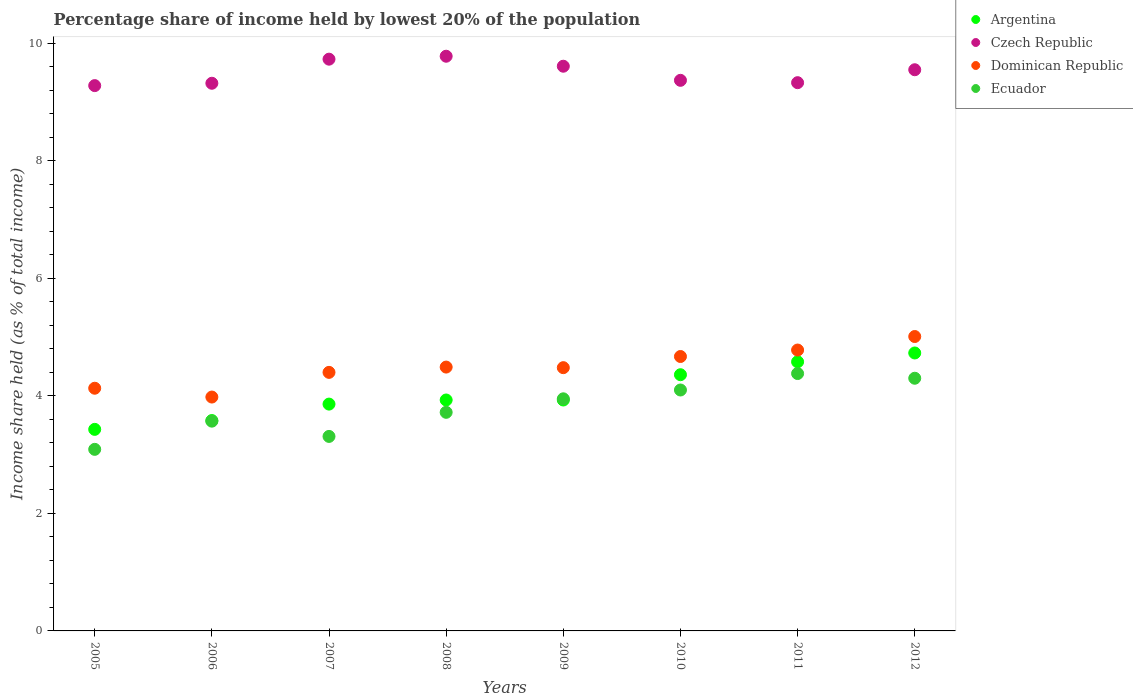Is the number of dotlines equal to the number of legend labels?
Offer a terse response. Yes. What is the percentage share of income held by lowest 20% of the population in Dominican Republic in 2006?
Keep it short and to the point. 3.98. Across all years, what is the maximum percentage share of income held by lowest 20% of the population in Czech Republic?
Keep it short and to the point. 9.78. Across all years, what is the minimum percentage share of income held by lowest 20% of the population in Ecuador?
Offer a very short reply. 3.09. In which year was the percentage share of income held by lowest 20% of the population in Argentina maximum?
Ensure brevity in your answer.  2012. What is the total percentage share of income held by lowest 20% of the population in Argentina in the graph?
Offer a very short reply. 32.4. What is the difference between the percentage share of income held by lowest 20% of the population in Czech Republic in 2006 and that in 2010?
Offer a terse response. -0.05. What is the difference between the percentage share of income held by lowest 20% of the population in Ecuador in 2011 and the percentage share of income held by lowest 20% of the population in Czech Republic in 2009?
Ensure brevity in your answer.  -5.23. What is the average percentage share of income held by lowest 20% of the population in Czech Republic per year?
Ensure brevity in your answer.  9.5. In the year 2008, what is the difference between the percentage share of income held by lowest 20% of the population in Czech Republic and percentage share of income held by lowest 20% of the population in Dominican Republic?
Provide a short and direct response. 5.29. What is the ratio of the percentage share of income held by lowest 20% of the population in Ecuador in 2005 to that in 2010?
Your answer should be very brief. 0.75. Is the percentage share of income held by lowest 20% of the population in Argentina in 2007 less than that in 2011?
Your answer should be very brief. Yes. What is the difference between the highest and the second highest percentage share of income held by lowest 20% of the population in Ecuador?
Your answer should be compact. 0.08. What is the difference between the highest and the lowest percentage share of income held by lowest 20% of the population in Ecuador?
Your answer should be compact. 1.29. In how many years, is the percentage share of income held by lowest 20% of the population in Ecuador greater than the average percentage share of income held by lowest 20% of the population in Ecuador taken over all years?
Offer a terse response. 4. Is the sum of the percentage share of income held by lowest 20% of the population in Argentina in 2005 and 2007 greater than the maximum percentage share of income held by lowest 20% of the population in Ecuador across all years?
Your answer should be compact. Yes. Is it the case that in every year, the sum of the percentage share of income held by lowest 20% of the population in Ecuador and percentage share of income held by lowest 20% of the population in Czech Republic  is greater than the sum of percentage share of income held by lowest 20% of the population in Dominican Republic and percentage share of income held by lowest 20% of the population in Argentina?
Provide a short and direct response. Yes. Does the percentage share of income held by lowest 20% of the population in Dominican Republic monotonically increase over the years?
Ensure brevity in your answer.  No. How many years are there in the graph?
Your answer should be compact. 8. What is the difference between two consecutive major ticks on the Y-axis?
Make the answer very short. 2. Does the graph contain grids?
Ensure brevity in your answer.  No. How are the legend labels stacked?
Ensure brevity in your answer.  Vertical. What is the title of the graph?
Make the answer very short. Percentage share of income held by lowest 20% of the population. What is the label or title of the X-axis?
Offer a terse response. Years. What is the label or title of the Y-axis?
Offer a terse response. Income share held (as % of total income). What is the Income share held (as % of total income) of Argentina in 2005?
Give a very brief answer. 3.43. What is the Income share held (as % of total income) of Czech Republic in 2005?
Your response must be concise. 9.28. What is the Income share held (as % of total income) of Dominican Republic in 2005?
Make the answer very short. 4.13. What is the Income share held (as % of total income) of Ecuador in 2005?
Offer a terse response. 3.09. What is the Income share held (as % of total income) of Argentina in 2006?
Your response must be concise. 3.58. What is the Income share held (as % of total income) of Czech Republic in 2006?
Give a very brief answer. 9.32. What is the Income share held (as % of total income) in Dominican Republic in 2006?
Give a very brief answer. 3.98. What is the Income share held (as % of total income) in Ecuador in 2006?
Provide a succinct answer. 3.57. What is the Income share held (as % of total income) of Argentina in 2007?
Provide a short and direct response. 3.86. What is the Income share held (as % of total income) of Czech Republic in 2007?
Your answer should be very brief. 9.73. What is the Income share held (as % of total income) of Ecuador in 2007?
Offer a terse response. 3.31. What is the Income share held (as % of total income) in Argentina in 2008?
Give a very brief answer. 3.93. What is the Income share held (as % of total income) in Czech Republic in 2008?
Ensure brevity in your answer.  9.78. What is the Income share held (as % of total income) of Dominican Republic in 2008?
Keep it short and to the point. 4.49. What is the Income share held (as % of total income) in Ecuador in 2008?
Ensure brevity in your answer.  3.72. What is the Income share held (as % of total income) of Argentina in 2009?
Ensure brevity in your answer.  3.93. What is the Income share held (as % of total income) in Czech Republic in 2009?
Your answer should be compact. 9.61. What is the Income share held (as % of total income) of Dominican Republic in 2009?
Provide a short and direct response. 4.48. What is the Income share held (as % of total income) of Ecuador in 2009?
Provide a short and direct response. 3.95. What is the Income share held (as % of total income) in Argentina in 2010?
Keep it short and to the point. 4.36. What is the Income share held (as % of total income) of Czech Republic in 2010?
Keep it short and to the point. 9.37. What is the Income share held (as % of total income) of Dominican Republic in 2010?
Give a very brief answer. 4.67. What is the Income share held (as % of total income) in Argentina in 2011?
Your answer should be very brief. 4.58. What is the Income share held (as % of total income) of Czech Republic in 2011?
Your answer should be compact. 9.33. What is the Income share held (as % of total income) of Dominican Republic in 2011?
Your response must be concise. 4.78. What is the Income share held (as % of total income) in Ecuador in 2011?
Give a very brief answer. 4.38. What is the Income share held (as % of total income) in Argentina in 2012?
Provide a short and direct response. 4.73. What is the Income share held (as % of total income) in Czech Republic in 2012?
Your answer should be very brief. 9.55. What is the Income share held (as % of total income) in Dominican Republic in 2012?
Give a very brief answer. 5.01. What is the Income share held (as % of total income) in Ecuador in 2012?
Your answer should be very brief. 4.3. Across all years, what is the maximum Income share held (as % of total income) of Argentina?
Offer a very short reply. 4.73. Across all years, what is the maximum Income share held (as % of total income) of Czech Republic?
Your answer should be compact. 9.78. Across all years, what is the maximum Income share held (as % of total income) of Dominican Republic?
Offer a terse response. 5.01. Across all years, what is the maximum Income share held (as % of total income) of Ecuador?
Ensure brevity in your answer.  4.38. Across all years, what is the minimum Income share held (as % of total income) of Argentina?
Offer a terse response. 3.43. Across all years, what is the minimum Income share held (as % of total income) of Czech Republic?
Keep it short and to the point. 9.28. Across all years, what is the minimum Income share held (as % of total income) of Dominican Republic?
Provide a succinct answer. 3.98. Across all years, what is the minimum Income share held (as % of total income) of Ecuador?
Your answer should be compact. 3.09. What is the total Income share held (as % of total income) of Argentina in the graph?
Provide a succinct answer. 32.4. What is the total Income share held (as % of total income) of Czech Republic in the graph?
Provide a short and direct response. 75.97. What is the total Income share held (as % of total income) of Dominican Republic in the graph?
Offer a very short reply. 35.94. What is the total Income share held (as % of total income) in Ecuador in the graph?
Your answer should be very brief. 30.42. What is the difference between the Income share held (as % of total income) of Argentina in 2005 and that in 2006?
Your answer should be very brief. -0.15. What is the difference between the Income share held (as % of total income) of Czech Republic in 2005 and that in 2006?
Give a very brief answer. -0.04. What is the difference between the Income share held (as % of total income) of Dominican Republic in 2005 and that in 2006?
Provide a short and direct response. 0.15. What is the difference between the Income share held (as % of total income) of Ecuador in 2005 and that in 2006?
Your response must be concise. -0.48. What is the difference between the Income share held (as % of total income) of Argentina in 2005 and that in 2007?
Make the answer very short. -0.43. What is the difference between the Income share held (as % of total income) of Czech Republic in 2005 and that in 2007?
Your answer should be compact. -0.45. What is the difference between the Income share held (as % of total income) of Dominican Republic in 2005 and that in 2007?
Make the answer very short. -0.27. What is the difference between the Income share held (as % of total income) of Ecuador in 2005 and that in 2007?
Your response must be concise. -0.22. What is the difference between the Income share held (as % of total income) in Argentina in 2005 and that in 2008?
Offer a very short reply. -0.5. What is the difference between the Income share held (as % of total income) in Czech Republic in 2005 and that in 2008?
Offer a terse response. -0.5. What is the difference between the Income share held (as % of total income) of Dominican Republic in 2005 and that in 2008?
Your response must be concise. -0.36. What is the difference between the Income share held (as % of total income) of Ecuador in 2005 and that in 2008?
Provide a short and direct response. -0.63. What is the difference between the Income share held (as % of total income) in Czech Republic in 2005 and that in 2009?
Your answer should be compact. -0.33. What is the difference between the Income share held (as % of total income) of Dominican Republic in 2005 and that in 2009?
Provide a succinct answer. -0.35. What is the difference between the Income share held (as % of total income) of Ecuador in 2005 and that in 2009?
Provide a succinct answer. -0.86. What is the difference between the Income share held (as % of total income) in Argentina in 2005 and that in 2010?
Give a very brief answer. -0.93. What is the difference between the Income share held (as % of total income) in Czech Republic in 2005 and that in 2010?
Make the answer very short. -0.09. What is the difference between the Income share held (as % of total income) of Dominican Republic in 2005 and that in 2010?
Make the answer very short. -0.54. What is the difference between the Income share held (as % of total income) of Ecuador in 2005 and that in 2010?
Your response must be concise. -1.01. What is the difference between the Income share held (as % of total income) of Argentina in 2005 and that in 2011?
Make the answer very short. -1.15. What is the difference between the Income share held (as % of total income) in Dominican Republic in 2005 and that in 2011?
Provide a succinct answer. -0.65. What is the difference between the Income share held (as % of total income) in Ecuador in 2005 and that in 2011?
Make the answer very short. -1.29. What is the difference between the Income share held (as % of total income) of Czech Republic in 2005 and that in 2012?
Keep it short and to the point. -0.27. What is the difference between the Income share held (as % of total income) of Dominican Republic in 2005 and that in 2012?
Make the answer very short. -0.88. What is the difference between the Income share held (as % of total income) of Ecuador in 2005 and that in 2012?
Keep it short and to the point. -1.21. What is the difference between the Income share held (as % of total income) in Argentina in 2006 and that in 2007?
Offer a very short reply. -0.28. What is the difference between the Income share held (as % of total income) of Czech Republic in 2006 and that in 2007?
Provide a short and direct response. -0.41. What is the difference between the Income share held (as % of total income) of Dominican Republic in 2006 and that in 2007?
Offer a terse response. -0.42. What is the difference between the Income share held (as % of total income) in Ecuador in 2006 and that in 2007?
Your answer should be very brief. 0.26. What is the difference between the Income share held (as % of total income) of Argentina in 2006 and that in 2008?
Give a very brief answer. -0.35. What is the difference between the Income share held (as % of total income) of Czech Republic in 2006 and that in 2008?
Offer a terse response. -0.46. What is the difference between the Income share held (as % of total income) in Dominican Republic in 2006 and that in 2008?
Provide a short and direct response. -0.51. What is the difference between the Income share held (as % of total income) of Argentina in 2006 and that in 2009?
Your answer should be compact. -0.35. What is the difference between the Income share held (as % of total income) in Czech Republic in 2006 and that in 2009?
Give a very brief answer. -0.29. What is the difference between the Income share held (as % of total income) of Ecuador in 2006 and that in 2009?
Offer a terse response. -0.38. What is the difference between the Income share held (as % of total income) of Argentina in 2006 and that in 2010?
Ensure brevity in your answer.  -0.78. What is the difference between the Income share held (as % of total income) in Dominican Republic in 2006 and that in 2010?
Your answer should be compact. -0.69. What is the difference between the Income share held (as % of total income) of Ecuador in 2006 and that in 2010?
Make the answer very short. -0.53. What is the difference between the Income share held (as % of total income) in Argentina in 2006 and that in 2011?
Offer a very short reply. -1. What is the difference between the Income share held (as % of total income) of Czech Republic in 2006 and that in 2011?
Provide a succinct answer. -0.01. What is the difference between the Income share held (as % of total income) in Dominican Republic in 2006 and that in 2011?
Your response must be concise. -0.8. What is the difference between the Income share held (as % of total income) of Ecuador in 2006 and that in 2011?
Provide a short and direct response. -0.81. What is the difference between the Income share held (as % of total income) of Argentina in 2006 and that in 2012?
Your response must be concise. -1.15. What is the difference between the Income share held (as % of total income) of Czech Republic in 2006 and that in 2012?
Ensure brevity in your answer.  -0.23. What is the difference between the Income share held (as % of total income) of Dominican Republic in 2006 and that in 2012?
Your answer should be very brief. -1.03. What is the difference between the Income share held (as % of total income) in Ecuador in 2006 and that in 2012?
Offer a very short reply. -0.73. What is the difference between the Income share held (as % of total income) in Argentina in 2007 and that in 2008?
Offer a very short reply. -0.07. What is the difference between the Income share held (as % of total income) of Dominican Republic in 2007 and that in 2008?
Your answer should be compact. -0.09. What is the difference between the Income share held (as % of total income) in Ecuador in 2007 and that in 2008?
Ensure brevity in your answer.  -0.41. What is the difference between the Income share held (as % of total income) of Argentina in 2007 and that in 2009?
Your answer should be compact. -0.07. What is the difference between the Income share held (as % of total income) in Czech Republic in 2007 and that in 2009?
Your answer should be compact. 0.12. What is the difference between the Income share held (as % of total income) of Dominican Republic in 2007 and that in 2009?
Make the answer very short. -0.08. What is the difference between the Income share held (as % of total income) of Ecuador in 2007 and that in 2009?
Keep it short and to the point. -0.64. What is the difference between the Income share held (as % of total income) in Argentina in 2007 and that in 2010?
Provide a succinct answer. -0.5. What is the difference between the Income share held (as % of total income) in Czech Republic in 2007 and that in 2010?
Offer a very short reply. 0.36. What is the difference between the Income share held (as % of total income) of Dominican Republic in 2007 and that in 2010?
Keep it short and to the point. -0.27. What is the difference between the Income share held (as % of total income) of Ecuador in 2007 and that in 2010?
Make the answer very short. -0.79. What is the difference between the Income share held (as % of total income) of Argentina in 2007 and that in 2011?
Give a very brief answer. -0.72. What is the difference between the Income share held (as % of total income) in Dominican Republic in 2007 and that in 2011?
Provide a succinct answer. -0.38. What is the difference between the Income share held (as % of total income) in Ecuador in 2007 and that in 2011?
Keep it short and to the point. -1.07. What is the difference between the Income share held (as % of total income) of Argentina in 2007 and that in 2012?
Provide a short and direct response. -0.87. What is the difference between the Income share held (as % of total income) of Czech Republic in 2007 and that in 2012?
Keep it short and to the point. 0.18. What is the difference between the Income share held (as % of total income) in Dominican Republic in 2007 and that in 2012?
Provide a short and direct response. -0.61. What is the difference between the Income share held (as % of total income) of Ecuador in 2007 and that in 2012?
Your answer should be compact. -0.99. What is the difference between the Income share held (as % of total income) of Czech Republic in 2008 and that in 2009?
Your response must be concise. 0.17. What is the difference between the Income share held (as % of total income) in Dominican Republic in 2008 and that in 2009?
Your answer should be compact. 0.01. What is the difference between the Income share held (as % of total income) in Ecuador in 2008 and that in 2009?
Provide a short and direct response. -0.23. What is the difference between the Income share held (as % of total income) of Argentina in 2008 and that in 2010?
Keep it short and to the point. -0.43. What is the difference between the Income share held (as % of total income) of Czech Republic in 2008 and that in 2010?
Give a very brief answer. 0.41. What is the difference between the Income share held (as % of total income) of Dominican Republic in 2008 and that in 2010?
Provide a short and direct response. -0.18. What is the difference between the Income share held (as % of total income) in Ecuador in 2008 and that in 2010?
Provide a short and direct response. -0.38. What is the difference between the Income share held (as % of total income) of Argentina in 2008 and that in 2011?
Offer a very short reply. -0.65. What is the difference between the Income share held (as % of total income) of Czech Republic in 2008 and that in 2011?
Your response must be concise. 0.45. What is the difference between the Income share held (as % of total income) in Dominican Republic in 2008 and that in 2011?
Keep it short and to the point. -0.29. What is the difference between the Income share held (as % of total income) in Ecuador in 2008 and that in 2011?
Your answer should be very brief. -0.66. What is the difference between the Income share held (as % of total income) of Czech Republic in 2008 and that in 2012?
Your answer should be very brief. 0.23. What is the difference between the Income share held (as % of total income) of Dominican Republic in 2008 and that in 2012?
Your answer should be very brief. -0.52. What is the difference between the Income share held (as % of total income) in Ecuador in 2008 and that in 2012?
Provide a succinct answer. -0.58. What is the difference between the Income share held (as % of total income) of Argentina in 2009 and that in 2010?
Your answer should be very brief. -0.43. What is the difference between the Income share held (as % of total income) in Czech Republic in 2009 and that in 2010?
Make the answer very short. 0.24. What is the difference between the Income share held (as % of total income) in Dominican Republic in 2009 and that in 2010?
Your answer should be very brief. -0.19. What is the difference between the Income share held (as % of total income) in Argentina in 2009 and that in 2011?
Offer a terse response. -0.65. What is the difference between the Income share held (as % of total income) in Czech Republic in 2009 and that in 2011?
Make the answer very short. 0.28. What is the difference between the Income share held (as % of total income) of Ecuador in 2009 and that in 2011?
Offer a terse response. -0.43. What is the difference between the Income share held (as % of total income) of Dominican Republic in 2009 and that in 2012?
Ensure brevity in your answer.  -0.53. What is the difference between the Income share held (as % of total income) in Ecuador in 2009 and that in 2012?
Make the answer very short. -0.35. What is the difference between the Income share held (as % of total income) of Argentina in 2010 and that in 2011?
Provide a succinct answer. -0.22. What is the difference between the Income share held (as % of total income) in Czech Republic in 2010 and that in 2011?
Your answer should be compact. 0.04. What is the difference between the Income share held (as % of total income) in Dominican Republic in 2010 and that in 2011?
Your response must be concise. -0.11. What is the difference between the Income share held (as % of total income) of Ecuador in 2010 and that in 2011?
Offer a very short reply. -0.28. What is the difference between the Income share held (as % of total income) in Argentina in 2010 and that in 2012?
Your response must be concise. -0.37. What is the difference between the Income share held (as % of total income) of Czech Republic in 2010 and that in 2012?
Give a very brief answer. -0.18. What is the difference between the Income share held (as % of total income) in Dominican Republic in 2010 and that in 2012?
Provide a succinct answer. -0.34. What is the difference between the Income share held (as % of total income) in Argentina in 2011 and that in 2012?
Provide a short and direct response. -0.15. What is the difference between the Income share held (as % of total income) in Czech Republic in 2011 and that in 2012?
Provide a succinct answer. -0.22. What is the difference between the Income share held (as % of total income) of Dominican Republic in 2011 and that in 2012?
Provide a succinct answer. -0.23. What is the difference between the Income share held (as % of total income) of Ecuador in 2011 and that in 2012?
Provide a short and direct response. 0.08. What is the difference between the Income share held (as % of total income) in Argentina in 2005 and the Income share held (as % of total income) in Czech Republic in 2006?
Keep it short and to the point. -5.89. What is the difference between the Income share held (as % of total income) of Argentina in 2005 and the Income share held (as % of total income) of Dominican Republic in 2006?
Offer a terse response. -0.55. What is the difference between the Income share held (as % of total income) of Argentina in 2005 and the Income share held (as % of total income) of Ecuador in 2006?
Your answer should be very brief. -0.14. What is the difference between the Income share held (as % of total income) of Czech Republic in 2005 and the Income share held (as % of total income) of Ecuador in 2006?
Give a very brief answer. 5.71. What is the difference between the Income share held (as % of total income) of Dominican Republic in 2005 and the Income share held (as % of total income) of Ecuador in 2006?
Provide a succinct answer. 0.56. What is the difference between the Income share held (as % of total income) of Argentina in 2005 and the Income share held (as % of total income) of Dominican Republic in 2007?
Keep it short and to the point. -0.97. What is the difference between the Income share held (as % of total income) in Argentina in 2005 and the Income share held (as % of total income) in Ecuador in 2007?
Your response must be concise. 0.12. What is the difference between the Income share held (as % of total income) of Czech Republic in 2005 and the Income share held (as % of total income) of Dominican Republic in 2007?
Ensure brevity in your answer.  4.88. What is the difference between the Income share held (as % of total income) of Czech Republic in 2005 and the Income share held (as % of total income) of Ecuador in 2007?
Your response must be concise. 5.97. What is the difference between the Income share held (as % of total income) in Dominican Republic in 2005 and the Income share held (as % of total income) in Ecuador in 2007?
Ensure brevity in your answer.  0.82. What is the difference between the Income share held (as % of total income) of Argentina in 2005 and the Income share held (as % of total income) of Czech Republic in 2008?
Your response must be concise. -6.35. What is the difference between the Income share held (as % of total income) of Argentina in 2005 and the Income share held (as % of total income) of Dominican Republic in 2008?
Make the answer very short. -1.06. What is the difference between the Income share held (as % of total income) in Argentina in 2005 and the Income share held (as % of total income) in Ecuador in 2008?
Your answer should be very brief. -0.29. What is the difference between the Income share held (as % of total income) of Czech Republic in 2005 and the Income share held (as % of total income) of Dominican Republic in 2008?
Your answer should be very brief. 4.79. What is the difference between the Income share held (as % of total income) of Czech Republic in 2005 and the Income share held (as % of total income) of Ecuador in 2008?
Offer a terse response. 5.56. What is the difference between the Income share held (as % of total income) of Dominican Republic in 2005 and the Income share held (as % of total income) of Ecuador in 2008?
Ensure brevity in your answer.  0.41. What is the difference between the Income share held (as % of total income) in Argentina in 2005 and the Income share held (as % of total income) in Czech Republic in 2009?
Make the answer very short. -6.18. What is the difference between the Income share held (as % of total income) of Argentina in 2005 and the Income share held (as % of total income) of Dominican Republic in 2009?
Provide a succinct answer. -1.05. What is the difference between the Income share held (as % of total income) in Argentina in 2005 and the Income share held (as % of total income) in Ecuador in 2009?
Give a very brief answer. -0.52. What is the difference between the Income share held (as % of total income) of Czech Republic in 2005 and the Income share held (as % of total income) of Ecuador in 2009?
Your answer should be very brief. 5.33. What is the difference between the Income share held (as % of total income) of Dominican Republic in 2005 and the Income share held (as % of total income) of Ecuador in 2009?
Your answer should be compact. 0.18. What is the difference between the Income share held (as % of total income) of Argentina in 2005 and the Income share held (as % of total income) of Czech Republic in 2010?
Provide a short and direct response. -5.94. What is the difference between the Income share held (as % of total income) in Argentina in 2005 and the Income share held (as % of total income) in Dominican Republic in 2010?
Your answer should be very brief. -1.24. What is the difference between the Income share held (as % of total income) of Argentina in 2005 and the Income share held (as % of total income) of Ecuador in 2010?
Keep it short and to the point. -0.67. What is the difference between the Income share held (as % of total income) of Czech Republic in 2005 and the Income share held (as % of total income) of Dominican Republic in 2010?
Make the answer very short. 4.61. What is the difference between the Income share held (as % of total income) in Czech Republic in 2005 and the Income share held (as % of total income) in Ecuador in 2010?
Your answer should be compact. 5.18. What is the difference between the Income share held (as % of total income) of Dominican Republic in 2005 and the Income share held (as % of total income) of Ecuador in 2010?
Ensure brevity in your answer.  0.03. What is the difference between the Income share held (as % of total income) in Argentina in 2005 and the Income share held (as % of total income) in Dominican Republic in 2011?
Provide a succinct answer. -1.35. What is the difference between the Income share held (as % of total income) of Argentina in 2005 and the Income share held (as % of total income) of Ecuador in 2011?
Your answer should be compact. -0.95. What is the difference between the Income share held (as % of total income) in Argentina in 2005 and the Income share held (as % of total income) in Czech Republic in 2012?
Your answer should be very brief. -6.12. What is the difference between the Income share held (as % of total income) in Argentina in 2005 and the Income share held (as % of total income) in Dominican Republic in 2012?
Your answer should be compact. -1.58. What is the difference between the Income share held (as % of total income) of Argentina in 2005 and the Income share held (as % of total income) of Ecuador in 2012?
Provide a succinct answer. -0.87. What is the difference between the Income share held (as % of total income) of Czech Republic in 2005 and the Income share held (as % of total income) of Dominican Republic in 2012?
Give a very brief answer. 4.27. What is the difference between the Income share held (as % of total income) of Czech Republic in 2005 and the Income share held (as % of total income) of Ecuador in 2012?
Your answer should be very brief. 4.98. What is the difference between the Income share held (as % of total income) of Dominican Republic in 2005 and the Income share held (as % of total income) of Ecuador in 2012?
Your response must be concise. -0.17. What is the difference between the Income share held (as % of total income) in Argentina in 2006 and the Income share held (as % of total income) in Czech Republic in 2007?
Offer a terse response. -6.15. What is the difference between the Income share held (as % of total income) of Argentina in 2006 and the Income share held (as % of total income) of Dominican Republic in 2007?
Your response must be concise. -0.82. What is the difference between the Income share held (as % of total income) in Argentina in 2006 and the Income share held (as % of total income) in Ecuador in 2007?
Offer a terse response. 0.27. What is the difference between the Income share held (as % of total income) of Czech Republic in 2006 and the Income share held (as % of total income) of Dominican Republic in 2007?
Provide a succinct answer. 4.92. What is the difference between the Income share held (as % of total income) of Czech Republic in 2006 and the Income share held (as % of total income) of Ecuador in 2007?
Offer a very short reply. 6.01. What is the difference between the Income share held (as % of total income) in Dominican Republic in 2006 and the Income share held (as % of total income) in Ecuador in 2007?
Keep it short and to the point. 0.67. What is the difference between the Income share held (as % of total income) of Argentina in 2006 and the Income share held (as % of total income) of Dominican Republic in 2008?
Make the answer very short. -0.91. What is the difference between the Income share held (as % of total income) of Argentina in 2006 and the Income share held (as % of total income) of Ecuador in 2008?
Offer a terse response. -0.14. What is the difference between the Income share held (as % of total income) of Czech Republic in 2006 and the Income share held (as % of total income) of Dominican Republic in 2008?
Offer a terse response. 4.83. What is the difference between the Income share held (as % of total income) of Dominican Republic in 2006 and the Income share held (as % of total income) of Ecuador in 2008?
Ensure brevity in your answer.  0.26. What is the difference between the Income share held (as % of total income) in Argentina in 2006 and the Income share held (as % of total income) in Czech Republic in 2009?
Give a very brief answer. -6.03. What is the difference between the Income share held (as % of total income) of Argentina in 2006 and the Income share held (as % of total income) of Ecuador in 2009?
Ensure brevity in your answer.  -0.37. What is the difference between the Income share held (as % of total income) of Czech Republic in 2006 and the Income share held (as % of total income) of Dominican Republic in 2009?
Provide a succinct answer. 4.84. What is the difference between the Income share held (as % of total income) in Czech Republic in 2006 and the Income share held (as % of total income) in Ecuador in 2009?
Ensure brevity in your answer.  5.37. What is the difference between the Income share held (as % of total income) of Dominican Republic in 2006 and the Income share held (as % of total income) of Ecuador in 2009?
Ensure brevity in your answer.  0.03. What is the difference between the Income share held (as % of total income) in Argentina in 2006 and the Income share held (as % of total income) in Czech Republic in 2010?
Give a very brief answer. -5.79. What is the difference between the Income share held (as % of total income) of Argentina in 2006 and the Income share held (as % of total income) of Dominican Republic in 2010?
Offer a terse response. -1.09. What is the difference between the Income share held (as % of total income) in Argentina in 2006 and the Income share held (as % of total income) in Ecuador in 2010?
Your answer should be compact. -0.52. What is the difference between the Income share held (as % of total income) of Czech Republic in 2006 and the Income share held (as % of total income) of Dominican Republic in 2010?
Make the answer very short. 4.65. What is the difference between the Income share held (as % of total income) of Czech Republic in 2006 and the Income share held (as % of total income) of Ecuador in 2010?
Keep it short and to the point. 5.22. What is the difference between the Income share held (as % of total income) in Dominican Republic in 2006 and the Income share held (as % of total income) in Ecuador in 2010?
Your answer should be compact. -0.12. What is the difference between the Income share held (as % of total income) in Argentina in 2006 and the Income share held (as % of total income) in Czech Republic in 2011?
Offer a terse response. -5.75. What is the difference between the Income share held (as % of total income) of Argentina in 2006 and the Income share held (as % of total income) of Dominican Republic in 2011?
Your response must be concise. -1.2. What is the difference between the Income share held (as % of total income) of Czech Republic in 2006 and the Income share held (as % of total income) of Dominican Republic in 2011?
Provide a succinct answer. 4.54. What is the difference between the Income share held (as % of total income) of Czech Republic in 2006 and the Income share held (as % of total income) of Ecuador in 2011?
Your answer should be compact. 4.94. What is the difference between the Income share held (as % of total income) of Dominican Republic in 2006 and the Income share held (as % of total income) of Ecuador in 2011?
Give a very brief answer. -0.4. What is the difference between the Income share held (as % of total income) of Argentina in 2006 and the Income share held (as % of total income) of Czech Republic in 2012?
Your response must be concise. -5.97. What is the difference between the Income share held (as % of total income) of Argentina in 2006 and the Income share held (as % of total income) of Dominican Republic in 2012?
Keep it short and to the point. -1.43. What is the difference between the Income share held (as % of total income) of Argentina in 2006 and the Income share held (as % of total income) of Ecuador in 2012?
Ensure brevity in your answer.  -0.72. What is the difference between the Income share held (as % of total income) of Czech Republic in 2006 and the Income share held (as % of total income) of Dominican Republic in 2012?
Offer a very short reply. 4.31. What is the difference between the Income share held (as % of total income) in Czech Republic in 2006 and the Income share held (as % of total income) in Ecuador in 2012?
Your response must be concise. 5.02. What is the difference between the Income share held (as % of total income) in Dominican Republic in 2006 and the Income share held (as % of total income) in Ecuador in 2012?
Offer a terse response. -0.32. What is the difference between the Income share held (as % of total income) of Argentina in 2007 and the Income share held (as % of total income) of Czech Republic in 2008?
Your answer should be very brief. -5.92. What is the difference between the Income share held (as % of total income) of Argentina in 2007 and the Income share held (as % of total income) of Dominican Republic in 2008?
Your response must be concise. -0.63. What is the difference between the Income share held (as % of total income) in Argentina in 2007 and the Income share held (as % of total income) in Ecuador in 2008?
Ensure brevity in your answer.  0.14. What is the difference between the Income share held (as % of total income) in Czech Republic in 2007 and the Income share held (as % of total income) in Dominican Republic in 2008?
Offer a very short reply. 5.24. What is the difference between the Income share held (as % of total income) of Czech Republic in 2007 and the Income share held (as % of total income) of Ecuador in 2008?
Offer a terse response. 6.01. What is the difference between the Income share held (as % of total income) in Dominican Republic in 2007 and the Income share held (as % of total income) in Ecuador in 2008?
Offer a very short reply. 0.68. What is the difference between the Income share held (as % of total income) in Argentina in 2007 and the Income share held (as % of total income) in Czech Republic in 2009?
Keep it short and to the point. -5.75. What is the difference between the Income share held (as % of total income) of Argentina in 2007 and the Income share held (as % of total income) of Dominican Republic in 2009?
Keep it short and to the point. -0.62. What is the difference between the Income share held (as % of total income) in Argentina in 2007 and the Income share held (as % of total income) in Ecuador in 2009?
Ensure brevity in your answer.  -0.09. What is the difference between the Income share held (as % of total income) in Czech Republic in 2007 and the Income share held (as % of total income) in Dominican Republic in 2009?
Keep it short and to the point. 5.25. What is the difference between the Income share held (as % of total income) in Czech Republic in 2007 and the Income share held (as % of total income) in Ecuador in 2009?
Your response must be concise. 5.78. What is the difference between the Income share held (as % of total income) of Dominican Republic in 2007 and the Income share held (as % of total income) of Ecuador in 2009?
Offer a very short reply. 0.45. What is the difference between the Income share held (as % of total income) of Argentina in 2007 and the Income share held (as % of total income) of Czech Republic in 2010?
Your answer should be very brief. -5.51. What is the difference between the Income share held (as % of total income) in Argentina in 2007 and the Income share held (as % of total income) in Dominican Republic in 2010?
Offer a terse response. -0.81. What is the difference between the Income share held (as % of total income) in Argentina in 2007 and the Income share held (as % of total income) in Ecuador in 2010?
Keep it short and to the point. -0.24. What is the difference between the Income share held (as % of total income) of Czech Republic in 2007 and the Income share held (as % of total income) of Dominican Republic in 2010?
Offer a terse response. 5.06. What is the difference between the Income share held (as % of total income) of Czech Republic in 2007 and the Income share held (as % of total income) of Ecuador in 2010?
Offer a terse response. 5.63. What is the difference between the Income share held (as % of total income) in Argentina in 2007 and the Income share held (as % of total income) in Czech Republic in 2011?
Offer a terse response. -5.47. What is the difference between the Income share held (as % of total income) in Argentina in 2007 and the Income share held (as % of total income) in Dominican Republic in 2011?
Keep it short and to the point. -0.92. What is the difference between the Income share held (as % of total income) of Argentina in 2007 and the Income share held (as % of total income) of Ecuador in 2011?
Offer a terse response. -0.52. What is the difference between the Income share held (as % of total income) in Czech Republic in 2007 and the Income share held (as % of total income) in Dominican Republic in 2011?
Provide a short and direct response. 4.95. What is the difference between the Income share held (as % of total income) of Czech Republic in 2007 and the Income share held (as % of total income) of Ecuador in 2011?
Your answer should be compact. 5.35. What is the difference between the Income share held (as % of total income) of Argentina in 2007 and the Income share held (as % of total income) of Czech Republic in 2012?
Keep it short and to the point. -5.69. What is the difference between the Income share held (as % of total income) of Argentina in 2007 and the Income share held (as % of total income) of Dominican Republic in 2012?
Offer a terse response. -1.15. What is the difference between the Income share held (as % of total income) of Argentina in 2007 and the Income share held (as % of total income) of Ecuador in 2012?
Your response must be concise. -0.44. What is the difference between the Income share held (as % of total income) of Czech Republic in 2007 and the Income share held (as % of total income) of Dominican Republic in 2012?
Offer a terse response. 4.72. What is the difference between the Income share held (as % of total income) in Czech Republic in 2007 and the Income share held (as % of total income) in Ecuador in 2012?
Your answer should be very brief. 5.43. What is the difference between the Income share held (as % of total income) in Dominican Republic in 2007 and the Income share held (as % of total income) in Ecuador in 2012?
Keep it short and to the point. 0.1. What is the difference between the Income share held (as % of total income) of Argentina in 2008 and the Income share held (as % of total income) of Czech Republic in 2009?
Offer a terse response. -5.68. What is the difference between the Income share held (as % of total income) of Argentina in 2008 and the Income share held (as % of total income) of Dominican Republic in 2009?
Keep it short and to the point. -0.55. What is the difference between the Income share held (as % of total income) of Argentina in 2008 and the Income share held (as % of total income) of Ecuador in 2009?
Offer a terse response. -0.02. What is the difference between the Income share held (as % of total income) of Czech Republic in 2008 and the Income share held (as % of total income) of Dominican Republic in 2009?
Provide a short and direct response. 5.3. What is the difference between the Income share held (as % of total income) in Czech Republic in 2008 and the Income share held (as % of total income) in Ecuador in 2009?
Your answer should be compact. 5.83. What is the difference between the Income share held (as % of total income) in Dominican Republic in 2008 and the Income share held (as % of total income) in Ecuador in 2009?
Give a very brief answer. 0.54. What is the difference between the Income share held (as % of total income) of Argentina in 2008 and the Income share held (as % of total income) of Czech Republic in 2010?
Your answer should be compact. -5.44. What is the difference between the Income share held (as % of total income) in Argentina in 2008 and the Income share held (as % of total income) in Dominican Republic in 2010?
Provide a short and direct response. -0.74. What is the difference between the Income share held (as % of total income) in Argentina in 2008 and the Income share held (as % of total income) in Ecuador in 2010?
Provide a short and direct response. -0.17. What is the difference between the Income share held (as % of total income) in Czech Republic in 2008 and the Income share held (as % of total income) in Dominican Republic in 2010?
Your answer should be very brief. 5.11. What is the difference between the Income share held (as % of total income) of Czech Republic in 2008 and the Income share held (as % of total income) of Ecuador in 2010?
Keep it short and to the point. 5.68. What is the difference between the Income share held (as % of total income) in Dominican Republic in 2008 and the Income share held (as % of total income) in Ecuador in 2010?
Offer a very short reply. 0.39. What is the difference between the Income share held (as % of total income) in Argentina in 2008 and the Income share held (as % of total income) in Czech Republic in 2011?
Make the answer very short. -5.4. What is the difference between the Income share held (as % of total income) of Argentina in 2008 and the Income share held (as % of total income) of Dominican Republic in 2011?
Keep it short and to the point. -0.85. What is the difference between the Income share held (as % of total income) in Argentina in 2008 and the Income share held (as % of total income) in Ecuador in 2011?
Your answer should be compact. -0.45. What is the difference between the Income share held (as % of total income) in Czech Republic in 2008 and the Income share held (as % of total income) in Dominican Republic in 2011?
Your response must be concise. 5. What is the difference between the Income share held (as % of total income) of Czech Republic in 2008 and the Income share held (as % of total income) of Ecuador in 2011?
Offer a terse response. 5.4. What is the difference between the Income share held (as % of total income) of Dominican Republic in 2008 and the Income share held (as % of total income) of Ecuador in 2011?
Provide a short and direct response. 0.11. What is the difference between the Income share held (as % of total income) of Argentina in 2008 and the Income share held (as % of total income) of Czech Republic in 2012?
Offer a very short reply. -5.62. What is the difference between the Income share held (as % of total income) in Argentina in 2008 and the Income share held (as % of total income) in Dominican Republic in 2012?
Make the answer very short. -1.08. What is the difference between the Income share held (as % of total income) in Argentina in 2008 and the Income share held (as % of total income) in Ecuador in 2012?
Give a very brief answer. -0.37. What is the difference between the Income share held (as % of total income) of Czech Republic in 2008 and the Income share held (as % of total income) of Dominican Republic in 2012?
Give a very brief answer. 4.77. What is the difference between the Income share held (as % of total income) in Czech Republic in 2008 and the Income share held (as % of total income) in Ecuador in 2012?
Your answer should be very brief. 5.48. What is the difference between the Income share held (as % of total income) of Dominican Republic in 2008 and the Income share held (as % of total income) of Ecuador in 2012?
Provide a succinct answer. 0.19. What is the difference between the Income share held (as % of total income) in Argentina in 2009 and the Income share held (as % of total income) in Czech Republic in 2010?
Provide a short and direct response. -5.44. What is the difference between the Income share held (as % of total income) in Argentina in 2009 and the Income share held (as % of total income) in Dominican Republic in 2010?
Offer a very short reply. -0.74. What is the difference between the Income share held (as % of total income) in Argentina in 2009 and the Income share held (as % of total income) in Ecuador in 2010?
Give a very brief answer. -0.17. What is the difference between the Income share held (as % of total income) in Czech Republic in 2009 and the Income share held (as % of total income) in Dominican Republic in 2010?
Keep it short and to the point. 4.94. What is the difference between the Income share held (as % of total income) of Czech Republic in 2009 and the Income share held (as % of total income) of Ecuador in 2010?
Provide a succinct answer. 5.51. What is the difference between the Income share held (as % of total income) in Dominican Republic in 2009 and the Income share held (as % of total income) in Ecuador in 2010?
Your answer should be compact. 0.38. What is the difference between the Income share held (as % of total income) of Argentina in 2009 and the Income share held (as % of total income) of Dominican Republic in 2011?
Provide a short and direct response. -0.85. What is the difference between the Income share held (as % of total income) of Argentina in 2009 and the Income share held (as % of total income) of Ecuador in 2011?
Make the answer very short. -0.45. What is the difference between the Income share held (as % of total income) of Czech Republic in 2009 and the Income share held (as % of total income) of Dominican Republic in 2011?
Your answer should be compact. 4.83. What is the difference between the Income share held (as % of total income) of Czech Republic in 2009 and the Income share held (as % of total income) of Ecuador in 2011?
Keep it short and to the point. 5.23. What is the difference between the Income share held (as % of total income) of Dominican Republic in 2009 and the Income share held (as % of total income) of Ecuador in 2011?
Your answer should be compact. 0.1. What is the difference between the Income share held (as % of total income) of Argentina in 2009 and the Income share held (as % of total income) of Czech Republic in 2012?
Your answer should be compact. -5.62. What is the difference between the Income share held (as % of total income) in Argentina in 2009 and the Income share held (as % of total income) in Dominican Republic in 2012?
Offer a very short reply. -1.08. What is the difference between the Income share held (as % of total income) of Argentina in 2009 and the Income share held (as % of total income) of Ecuador in 2012?
Your response must be concise. -0.37. What is the difference between the Income share held (as % of total income) of Czech Republic in 2009 and the Income share held (as % of total income) of Dominican Republic in 2012?
Make the answer very short. 4.6. What is the difference between the Income share held (as % of total income) of Czech Republic in 2009 and the Income share held (as % of total income) of Ecuador in 2012?
Ensure brevity in your answer.  5.31. What is the difference between the Income share held (as % of total income) of Dominican Republic in 2009 and the Income share held (as % of total income) of Ecuador in 2012?
Provide a succinct answer. 0.18. What is the difference between the Income share held (as % of total income) in Argentina in 2010 and the Income share held (as % of total income) in Czech Republic in 2011?
Provide a succinct answer. -4.97. What is the difference between the Income share held (as % of total income) of Argentina in 2010 and the Income share held (as % of total income) of Dominican Republic in 2011?
Provide a succinct answer. -0.42. What is the difference between the Income share held (as % of total income) in Argentina in 2010 and the Income share held (as % of total income) in Ecuador in 2011?
Ensure brevity in your answer.  -0.02. What is the difference between the Income share held (as % of total income) in Czech Republic in 2010 and the Income share held (as % of total income) in Dominican Republic in 2011?
Make the answer very short. 4.59. What is the difference between the Income share held (as % of total income) of Czech Republic in 2010 and the Income share held (as % of total income) of Ecuador in 2011?
Your answer should be very brief. 4.99. What is the difference between the Income share held (as % of total income) in Dominican Republic in 2010 and the Income share held (as % of total income) in Ecuador in 2011?
Your answer should be very brief. 0.29. What is the difference between the Income share held (as % of total income) of Argentina in 2010 and the Income share held (as % of total income) of Czech Republic in 2012?
Offer a terse response. -5.19. What is the difference between the Income share held (as % of total income) in Argentina in 2010 and the Income share held (as % of total income) in Dominican Republic in 2012?
Offer a terse response. -0.65. What is the difference between the Income share held (as % of total income) of Czech Republic in 2010 and the Income share held (as % of total income) of Dominican Republic in 2012?
Your answer should be very brief. 4.36. What is the difference between the Income share held (as % of total income) of Czech Republic in 2010 and the Income share held (as % of total income) of Ecuador in 2012?
Keep it short and to the point. 5.07. What is the difference between the Income share held (as % of total income) of Dominican Republic in 2010 and the Income share held (as % of total income) of Ecuador in 2012?
Provide a succinct answer. 0.37. What is the difference between the Income share held (as % of total income) of Argentina in 2011 and the Income share held (as % of total income) of Czech Republic in 2012?
Your answer should be compact. -4.97. What is the difference between the Income share held (as % of total income) of Argentina in 2011 and the Income share held (as % of total income) of Dominican Republic in 2012?
Offer a very short reply. -0.43. What is the difference between the Income share held (as % of total income) in Argentina in 2011 and the Income share held (as % of total income) in Ecuador in 2012?
Provide a short and direct response. 0.28. What is the difference between the Income share held (as % of total income) of Czech Republic in 2011 and the Income share held (as % of total income) of Dominican Republic in 2012?
Ensure brevity in your answer.  4.32. What is the difference between the Income share held (as % of total income) of Czech Republic in 2011 and the Income share held (as % of total income) of Ecuador in 2012?
Your answer should be very brief. 5.03. What is the difference between the Income share held (as % of total income) in Dominican Republic in 2011 and the Income share held (as % of total income) in Ecuador in 2012?
Provide a short and direct response. 0.48. What is the average Income share held (as % of total income) of Argentina per year?
Provide a succinct answer. 4.05. What is the average Income share held (as % of total income) in Czech Republic per year?
Make the answer very short. 9.5. What is the average Income share held (as % of total income) of Dominican Republic per year?
Offer a terse response. 4.49. What is the average Income share held (as % of total income) in Ecuador per year?
Your answer should be compact. 3.8. In the year 2005, what is the difference between the Income share held (as % of total income) in Argentina and Income share held (as % of total income) in Czech Republic?
Your answer should be very brief. -5.85. In the year 2005, what is the difference between the Income share held (as % of total income) in Argentina and Income share held (as % of total income) in Dominican Republic?
Provide a succinct answer. -0.7. In the year 2005, what is the difference between the Income share held (as % of total income) of Argentina and Income share held (as % of total income) of Ecuador?
Your answer should be very brief. 0.34. In the year 2005, what is the difference between the Income share held (as % of total income) of Czech Republic and Income share held (as % of total income) of Dominican Republic?
Keep it short and to the point. 5.15. In the year 2005, what is the difference between the Income share held (as % of total income) of Czech Republic and Income share held (as % of total income) of Ecuador?
Provide a succinct answer. 6.19. In the year 2006, what is the difference between the Income share held (as % of total income) of Argentina and Income share held (as % of total income) of Czech Republic?
Offer a very short reply. -5.74. In the year 2006, what is the difference between the Income share held (as % of total income) of Argentina and Income share held (as % of total income) of Dominican Republic?
Make the answer very short. -0.4. In the year 2006, what is the difference between the Income share held (as % of total income) in Argentina and Income share held (as % of total income) in Ecuador?
Provide a succinct answer. 0.01. In the year 2006, what is the difference between the Income share held (as % of total income) in Czech Republic and Income share held (as % of total income) in Dominican Republic?
Offer a very short reply. 5.34. In the year 2006, what is the difference between the Income share held (as % of total income) in Czech Republic and Income share held (as % of total income) in Ecuador?
Ensure brevity in your answer.  5.75. In the year 2006, what is the difference between the Income share held (as % of total income) in Dominican Republic and Income share held (as % of total income) in Ecuador?
Your answer should be compact. 0.41. In the year 2007, what is the difference between the Income share held (as % of total income) in Argentina and Income share held (as % of total income) in Czech Republic?
Offer a terse response. -5.87. In the year 2007, what is the difference between the Income share held (as % of total income) of Argentina and Income share held (as % of total income) of Dominican Republic?
Your response must be concise. -0.54. In the year 2007, what is the difference between the Income share held (as % of total income) of Argentina and Income share held (as % of total income) of Ecuador?
Give a very brief answer. 0.55. In the year 2007, what is the difference between the Income share held (as % of total income) of Czech Republic and Income share held (as % of total income) of Dominican Republic?
Give a very brief answer. 5.33. In the year 2007, what is the difference between the Income share held (as % of total income) of Czech Republic and Income share held (as % of total income) of Ecuador?
Provide a succinct answer. 6.42. In the year 2007, what is the difference between the Income share held (as % of total income) in Dominican Republic and Income share held (as % of total income) in Ecuador?
Make the answer very short. 1.09. In the year 2008, what is the difference between the Income share held (as % of total income) in Argentina and Income share held (as % of total income) in Czech Republic?
Your answer should be compact. -5.85. In the year 2008, what is the difference between the Income share held (as % of total income) in Argentina and Income share held (as % of total income) in Dominican Republic?
Give a very brief answer. -0.56. In the year 2008, what is the difference between the Income share held (as % of total income) in Argentina and Income share held (as % of total income) in Ecuador?
Offer a very short reply. 0.21. In the year 2008, what is the difference between the Income share held (as % of total income) in Czech Republic and Income share held (as % of total income) in Dominican Republic?
Provide a succinct answer. 5.29. In the year 2008, what is the difference between the Income share held (as % of total income) in Czech Republic and Income share held (as % of total income) in Ecuador?
Give a very brief answer. 6.06. In the year 2008, what is the difference between the Income share held (as % of total income) of Dominican Republic and Income share held (as % of total income) of Ecuador?
Provide a short and direct response. 0.77. In the year 2009, what is the difference between the Income share held (as % of total income) of Argentina and Income share held (as % of total income) of Czech Republic?
Provide a short and direct response. -5.68. In the year 2009, what is the difference between the Income share held (as % of total income) of Argentina and Income share held (as % of total income) of Dominican Republic?
Your answer should be compact. -0.55. In the year 2009, what is the difference between the Income share held (as % of total income) in Argentina and Income share held (as % of total income) in Ecuador?
Provide a succinct answer. -0.02. In the year 2009, what is the difference between the Income share held (as % of total income) in Czech Republic and Income share held (as % of total income) in Dominican Republic?
Your answer should be very brief. 5.13. In the year 2009, what is the difference between the Income share held (as % of total income) in Czech Republic and Income share held (as % of total income) in Ecuador?
Keep it short and to the point. 5.66. In the year 2009, what is the difference between the Income share held (as % of total income) in Dominican Republic and Income share held (as % of total income) in Ecuador?
Provide a short and direct response. 0.53. In the year 2010, what is the difference between the Income share held (as % of total income) of Argentina and Income share held (as % of total income) of Czech Republic?
Your answer should be very brief. -5.01. In the year 2010, what is the difference between the Income share held (as % of total income) of Argentina and Income share held (as % of total income) of Dominican Republic?
Provide a short and direct response. -0.31. In the year 2010, what is the difference between the Income share held (as % of total income) in Argentina and Income share held (as % of total income) in Ecuador?
Keep it short and to the point. 0.26. In the year 2010, what is the difference between the Income share held (as % of total income) of Czech Republic and Income share held (as % of total income) of Ecuador?
Make the answer very short. 5.27. In the year 2010, what is the difference between the Income share held (as % of total income) of Dominican Republic and Income share held (as % of total income) of Ecuador?
Ensure brevity in your answer.  0.57. In the year 2011, what is the difference between the Income share held (as % of total income) of Argentina and Income share held (as % of total income) of Czech Republic?
Make the answer very short. -4.75. In the year 2011, what is the difference between the Income share held (as % of total income) in Czech Republic and Income share held (as % of total income) in Dominican Republic?
Provide a short and direct response. 4.55. In the year 2011, what is the difference between the Income share held (as % of total income) in Czech Republic and Income share held (as % of total income) in Ecuador?
Your answer should be compact. 4.95. In the year 2012, what is the difference between the Income share held (as % of total income) in Argentina and Income share held (as % of total income) in Czech Republic?
Keep it short and to the point. -4.82. In the year 2012, what is the difference between the Income share held (as % of total income) in Argentina and Income share held (as % of total income) in Dominican Republic?
Make the answer very short. -0.28. In the year 2012, what is the difference between the Income share held (as % of total income) in Argentina and Income share held (as % of total income) in Ecuador?
Your response must be concise. 0.43. In the year 2012, what is the difference between the Income share held (as % of total income) of Czech Republic and Income share held (as % of total income) of Dominican Republic?
Make the answer very short. 4.54. In the year 2012, what is the difference between the Income share held (as % of total income) in Czech Republic and Income share held (as % of total income) in Ecuador?
Make the answer very short. 5.25. In the year 2012, what is the difference between the Income share held (as % of total income) in Dominican Republic and Income share held (as % of total income) in Ecuador?
Your answer should be compact. 0.71. What is the ratio of the Income share held (as % of total income) of Argentina in 2005 to that in 2006?
Your response must be concise. 0.96. What is the ratio of the Income share held (as % of total income) of Dominican Republic in 2005 to that in 2006?
Your answer should be compact. 1.04. What is the ratio of the Income share held (as % of total income) of Ecuador in 2005 to that in 2006?
Make the answer very short. 0.87. What is the ratio of the Income share held (as % of total income) of Argentina in 2005 to that in 2007?
Offer a terse response. 0.89. What is the ratio of the Income share held (as % of total income) in Czech Republic in 2005 to that in 2007?
Offer a very short reply. 0.95. What is the ratio of the Income share held (as % of total income) of Dominican Republic in 2005 to that in 2007?
Offer a terse response. 0.94. What is the ratio of the Income share held (as % of total income) of Ecuador in 2005 to that in 2007?
Your response must be concise. 0.93. What is the ratio of the Income share held (as % of total income) in Argentina in 2005 to that in 2008?
Your response must be concise. 0.87. What is the ratio of the Income share held (as % of total income) of Czech Republic in 2005 to that in 2008?
Give a very brief answer. 0.95. What is the ratio of the Income share held (as % of total income) in Dominican Republic in 2005 to that in 2008?
Your answer should be very brief. 0.92. What is the ratio of the Income share held (as % of total income) of Ecuador in 2005 to that in 2008?
Provide a succinct answer. 0.83. What is the ratio of the Income share held (as % of total income) of Argentina in 2005 to that in 2009?
Your response must be concise. 0.87. What is the ratio of the Income share held (as % of total income) of Czech Republic in 2005 to that in 2009?
Provide a succinct answer. 0.97. What is the ratio of the Income share held (as % of total income) of Dominican Republic in 2005 to that in 2009?
Your answer should be compact. 0.92. What is the ratio of the Income share held (as % of total income) in Ecuador in 2005 to that in 2009?
Ensure brevity in your answer.  0.78. What is the ratio of the Income share held (as % of total income) of Argentina in 2005 to that in 2010?
Offer a very short reply. 0.79. What is the ratio of the Income share held (as % of total income) of Czech Republic in 2005 to that in 2010?
Give a very brief answer. 0.99. What is the ratio of the Income share held (as % of total income) in Dominican Republic in 2005 to that in 2010?
Give a very brief answer. 0.88. What is the ratio of the Income share held (as % of total income) of Ecuador in 2005 to that in 2010?
Provide a short and direct response. 0.75. What is the ratio of the Income share held (as % of total income) in Argentina in 2005 to that in 2011?
Keep it short and to the point. 0.75. What is the ratio of the Income share held (as % of total income) in Dominican Republic in 2005 to that in 2011?
Your answer should be compact. 0.86. What is the ratio of the Income share held (as % of total income) in Ecuador in 2005 to that in 2011?
Offer a terse response. 0.71. What is the ratio of the Income share held (as % of total income) in Argentina in 2005 to that in 2012?
Your answer should be compact. 0.73. What is the ratio of the Income share held (as % of total income) of Czech Republic in 2005 to that in 2012?
Keep it short and to the point. 0.97. What is the ratio of the Income share held (as % of total income) of Dominican Republic in 2005 to that in 2012?
Provide a succinct answer. 0.82. What is the ratio of the Income share held (as % of total income) in Ecuador in 2005 to that in 2012?
Your response must be concise. 0.72. What is the ratio of the Income share held (as % of total income) in Argentina in 2006 to that in 2007?
Give a very brief answer. 0.93. What is the ratio of the Income share held (as % of total income) of Czech Republic in 2006 to that in 2007?
Ensure brevity in your answer.  0.96. What is the ratio of the Income share held (as % of total income) of Dominican Republic in 2006 to that in 2007?
Provide a short and direct response. 0.9. What is the ratio of the Income share held (as % of total income) in Ecuador in 2006 to that in 2007?
Offer a terse response. 1.08. What is the ratio of the Income share held (as % of total income) of Argentina in 2006 to that in 2008?
Provide a succinct answer. 0.91. What is the ratio of the Income share held (as % of total income) of Czech Republic in 2006 to that in 2008?
Provide a short and direct response. 0.95. What is the ratio of the Income share held (as % of total income) of Dominican Republic in 2006 to that in 2008?
Offer a very short reply. 0.89. What is the ratio of the Income share held (as % of total income) of Ecuador in 2006 to that in 2008?
Make the answer very short. 0.96. What is the ratio of the Income share held (as % of total income) in Argentina in 2006 to that in 2009?
Your response must be concise. 0.91. What is the ratio of the Income share held (as % of total income) of Czech Republic in 2006 to that in 2009?
Offer a terse response. 0.97. What is the ratio of the Income share held (as % of total income) of Dominican Republic in 2006 to that in 2009?
Provide a short and direct response. 0.89. What is the ratio of the Income share held (as % of total income) in Ecuador in 2006 to that in 2009?
Your answer should be very brief. 0.9. What is the ratio of the Income share held (as % of total income) of Argentina in 2006 to that in 2010?
Make the answer very short. 0.82. What is the ratio of the Income share held (as % of total income) of Dominican Republic in 2006 to that in 2010?
Offer a terse response. 0.85. What is the ratio of the Income share held (as % of total income) in Ecuador in 2006 to that in 2010?
Give a very brief answer. 0.87. What is the ratio of the Income share held (as % of total income) of Argentina in 2006 to that in 2011?
Provide a succinct answer. 0.78. What is the ratio of the Income share held (as % of total income) of Dominican Republic in 2006 to that in 2011?
Keep it short and to the point. 0.83. What is the ratio of the Income share held (as % of total income) in Ecuador in 2006 to that in 2011?
Ensure brevity in your answer.  0.82. What is the ratio of the Income share held (as % of total income) in Argentina in 2006 to that in 2012?
Offer a very short reply. 0.76. What is the ratio of the Income share held (as % of total income) in Czech Republic in 2006 to that in 2012?
Your answer should be very brief. 0.98. What is the ratio of the Income share held (as % of total income) in Dominican Republic in 2006 to that in 2012?
Your answer should be very brief. 0.79. What is the ratio of the Income share held (as % of total income) of Ecuador in 2006 to that in 2012?
Offer a terse response. 0.83. What is the ratio of the Income share held (as % of total income) in Argentina in 2007 to that in 2008?
Offer a very short reply. 0.98. What is the ratio of the Income share held (as % of total income) of Dominican Republic in 2007 to that in 2008?
Provide a short and direct response. 0.98. What is the ratio of the Income share held (as % of total income) in Ecuador in 2007 to that in 2008?
Keep it short and to the point. 0.89. What is the ratio of the Income share held (as % of total income) of Argentina in 2007 to that in 2009?
Offer a terse response. 0.98. What is the ratio of the Income share held (as % of total income) of Czech Republic in 2007 to that in 2009?
Your response must be concise. 1.01. What is the ratio of the Income share held (as % of total income) in Dominican Republic in 2007 to that in 2009?
Keep it short and to the point. 0.98. What is the ratio of the Income share held (as % of total income) in Ecuador in 2007 to that in 2009?
Give a very brief answer. 0.84. What is the ratio of the Income share held (as % of total income) of Argentina in 2007 to that in 2010?
Provide a succinct answer. 0.89. What is the ratio of the Income share held (as % of total income) of Czech Republic in 2007 to that in 2010?
Ensure brevity in your answer.  1.04. What is the ratio of the Income share held (as % of total income) of Dominican Republic in 2007 to that in 2010?
Your answer should be very brief. 0.94. What is the ratio of the Income share held (as % of total income) of Ecuador in 2007 to that in 2010?
Provide a short and direct response. 0.81. What is the ratio of the Income share held (as % of total income) of Argentina in 2007 to that in 2011?
Make the answer very short. 0.84. What is the ratio of the Income share held (as % of total income) of Czech Republic in 2007 to that in 2011?
Give a very brief answer. 1.04. What is the ratio of the Income share held (as % of total income) of Dominican Republic in 2007 to that in 2011?
Provide a succinct answer. 0.92. What is the ratio of the Income share held (as % of total income) of Ecuador in 2007 to that in 2011?
Your answer should be compact. 0.76. What is the ratio of the Income share held (as % of total income) of Argentina in 2007 to that in 2012?
Your answer should be compact. 0.82. What is the ratio of the Income share held (as % of total income) in Czech Republic in 2007 to that in 2012?
Your answer should be very brief. 1.02. What is the ratio of the Income share held (as % of total income) of Dominican Republic in 2007 to that in 2012?
Provide a short and direct response. 0.88. What is the ratio of the Income share held (as % of total income) of Ecuador in 2007 to that in 2012?
Your answer should be compact. 0.77. What is the ratio of the Income share held (as % of total income) of Argentina in 2008 to that in 2009?
Ensure brevity in your answer.  1. What is the ratio of the Income share held (as % of total income) of Czech Republic in 2008 to that in 2009?
Make the answer very short. 1.02. What is the ratio of the Income share held (as % of total income) in Dominican Republic in 2008 to that in 2009?
Offer a very short reply. 1. What is the ratio of the Income share held (as % of total income) of Ecuador in 2008 to that in 2009?
Make the answer very short. 0.94. What is the ratio of the Income share held (as % of total income) in Argentina in 2008 to that in 2010?
Your response must be concise. 0.9. What is the ratio of the Income share held (as % of total income) of Czech Republic in 2008 to that in 2010?
Keep it short and to the point. 1.04. What is the ratio of the Income share held (as % of total income) in Dominican Republic in 2008 to that in 2010?
Give a very brief answer. 0.96. What is the ratio of the Income share held (as % of total income) in Ecuador in 2008 to that in 2010?
Your answer should be very brief. 0.91. What is the ratio of the Income share held (as % of total income) in Argentina in 2008 to that in 2011?
Your answer should be compact. 0.86. What is the ratio of the Income share held (as % of total income) in Czech Republic in 2008 to that in 2011?
Provide a short and direct response. 1.05. What is the ratio of the Income share held (as % of total income) in Dominican Republic in 2008 to that in 2011?
Your response must be concise. 0.94. What is the ratio of the Income share held (as % of total income) of Ecuador in 2008 to that in 2011?
Your response must be concise. 0.85. What is the ratio of the Income share held (as % of total income) of Argentina in 2008 to that in 2012?
Give a very brief answer. 0.83. What is the ratio of the Income share held (as % of total income) in Czech Republic in 2008 to that in 2012?
Offer a very short reply. 1.02. What is the ratio of the Income share held (as % of total income) of Dominican Republic in 2008 to that in 2012?
Make the answer very short. 0.9. What is the ratio of the Income share held (as % of total income) in Ecuador in 2008 to that in 2012?
Your answer should be compact. 0.87. What is the ratio of the Income share held (as % of total income) of Argentina in 2009 to that in 2010?
Provide a succinct answer. 0.9. What is the ratio of the Income share held (as % of total income) of Czech Republic in 2009 to that in 2010?
Offer a terse response. 1.03. What is the ratio of the Income share held (as % of total income) of Dominican Republic in 2009 to that in 2010?
Your response must be concise. 0.96. What is the ratio of the Income share held (as % of total income) in Ecuador in 2009 to that in 2010?
Keep it short and to the point. 0.96. What is the ratio of the Income share held (as % of total income) of Argentina in 2009 to that in 2011?
Offer a terse response. 0.86. What is the ratio of the Income share held (as % of total income) in Dominican Republic in 2009 to that in 2011?
Offer a very short reply. 0.94. What is the ratio of the Income share held (as % of total income) in Ecuador in 2009 to that in 2011?
Provide a succinct answer. 0.9. What is the ratio of the Income share held (as % of total income) of Argentina in 2009 to that in 2012?
Give a very brief answer. 0.83. What is the ratio of the Income share held (as % of total income) of Czech Republic in 2009 to that in 2012?
Offer a terse response. 1.01. What is the ratio of the Income share held (as % of total income) in Dominican Republic in 2009 to that in 2012?
Your response must be concise. 0.89. What is the ratio of the Income share held (as % of total income) in Ecuador in 2009 to that in 2012?
Make the answer very short. 0.92. What is the ratio of the Income share held (as % of total income) of Czech Republic in 2010 to that in 2011?
Make the answer very short. 1. What is the ratio of the Income share held (as % of total income) in Dominican Republic in 2010 to that in 2011?
Provide a succinct answer. 0.98. What is the ratio of the Income share held (as % of total income) in Ecuador in 2010 to that in 2011?
Offer a terse response. 0.94. What is the ratio of the Income share held (as % of total income) of Argentina in 2010 to that in 2012?
Offer a very short reply. 0.92. What is the ratio of the Income share held (as % of total income) of Czech Republic in 2010 to that in 2012?
Your response must be concise. 0.98. What is the ratio of the Income share held (as % of total income) in Dominican Republic in 2010 to that in 2012?
Provide a succinct answer. 0.93. What is the ratio of the Income share held (as % of total income) of Ecuador in 2010 to that in 2012?
Provide a short and direct response. 0.95. What is the ratio of the Income share held (as % of total income) in Argentina in 2011 to that in 2012?
Ensure brevity in your answer.  0.97. What is the ratio of the Income share held (as % of total income) of Czech Republic in 2011 to that in 2012?
Offer a terse response. 0.98. What is the ratio of the Income share held (as % of total income) in Dominican Republic in 2011 to that in 2012?
Your response must be concise. 0.95. What is the ratio of the Income share held (as % of total income) of Ecuador in 2011 to that in 2012?
Offer a terse response. 1.02. What is the difference between the highest and the second highest Income share held (as % of total income) of Dominican Republic?
Provide a short and direct response. 0.23. What is the difference between the highest and the lowest Income share held (as % of total income) of Argentina?
Offer a terse response. 1.3. What is the difference between the highest and the lowest Income share held (as % of total income) in Czech Republic?
Ensure brevity in your answer.  0.5. What is the difference between the highest and the lowest Income share held (as % of total income) in Dominican Republic?
Your response must be concise. 1.03. What is the difference between the highest and the lowest Income share held (as % of total income) in Ecuador?
Offer a terse response. 1.29. 